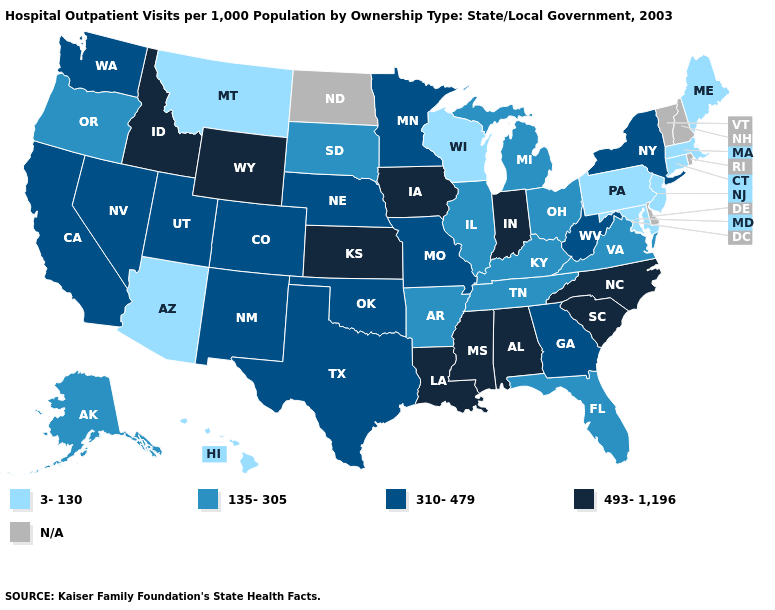What is the value of Wyoming?
Concise answer only. 493-1,196. How many symbols are there in the legend?
Short answer required. 5. What is the value of Wyoming?
Keep it brief. 493-1,196. Among the states that border Wisconsin , which have the highest value?
Concise answer only. Iowa. Name the states that have a value in the range 3-130?
Keep it brief. Arizona, Connecticut, Hawaii, Maine, Maryland, Massachusetts, Montana, New Jersey, Pennsylvania, Wisconsin. Among the states that border North Carolina , does Virginia have the lowest value?
Be succinct. Yes. Name the states that have a value in the range 310-479?
Answer briefly. California, Colorado, Georgia, Minnesota, Missouri, Nebraska, Nevada, New Mexico, New York, Oklahoma, Texas, Utah, Washington, West Virginia. Which states have the lowest value in the South?
Be succinct. Maryland. What is the highest value in states that border California?
Keep it brief. 310-479. Does Maryland have the lowest value in the USA?
Answer briefly. Yes. 